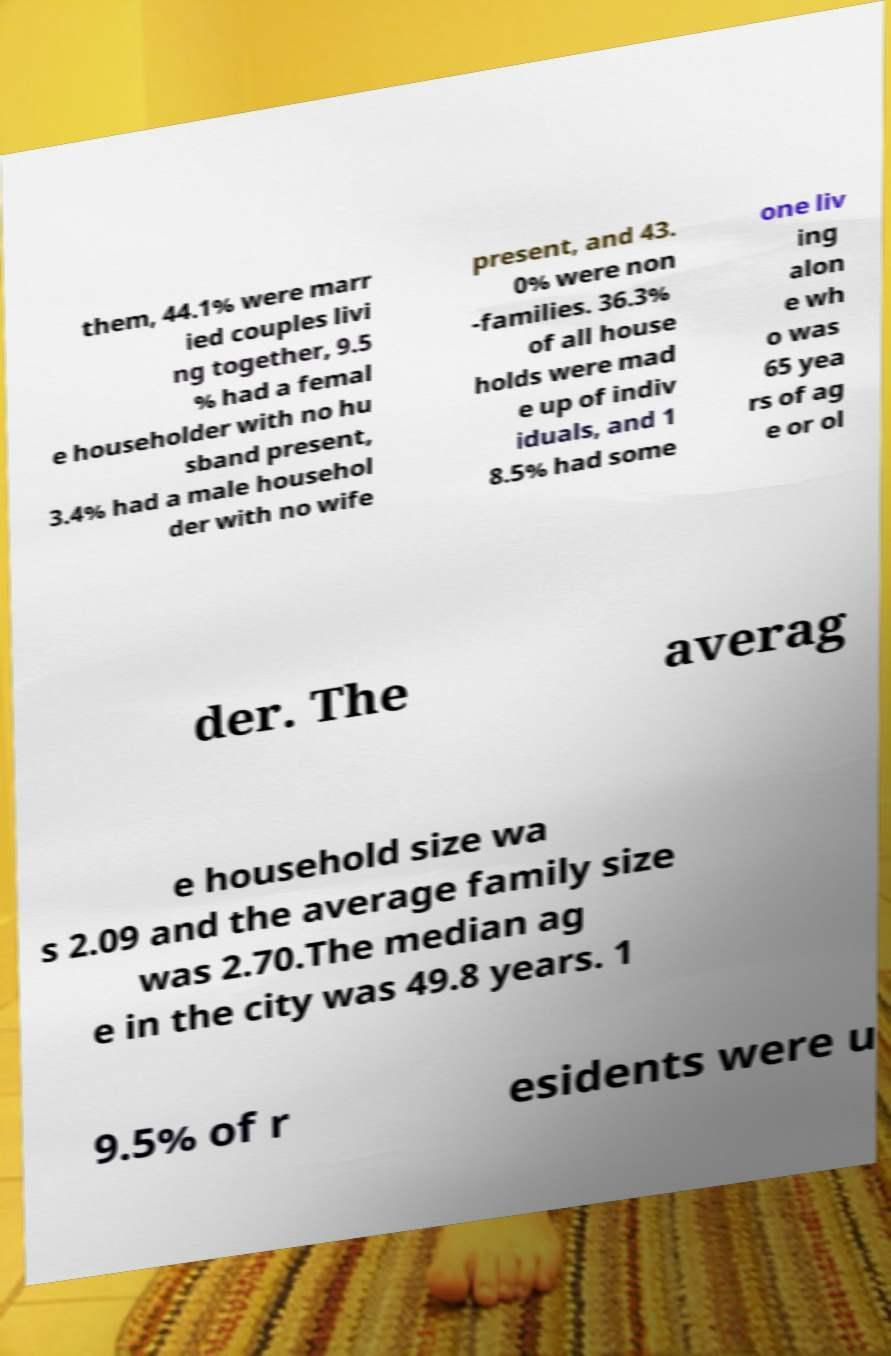I need the written content from this picture converted into text. Can you do that? them, 44.1% were marr ied couples livi ng together, 9.5 % had a femal e householder with no hu sband present, 3.4% had a male househol der with no wife present, and 43. 0% were non -families. 36.3% of all house holds were mad e up of indiv iduals, and 1 8.5% had some one liv ing alon e wh o was 65 yea rs of ag e or ol der. The averag e household size wa s 2.09 and the average family size was 2.70.The median ag e in the city was 49.8 years. 1 9.5% of r esidents were u 